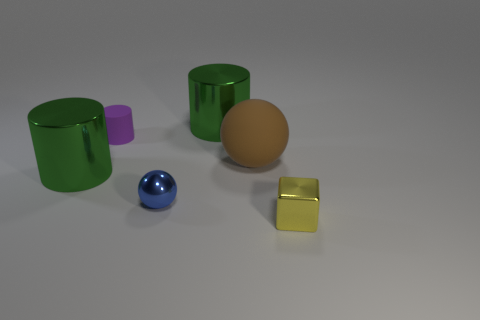Add 1 gray spheres. How many objects exist? 7 Subtract all balls. How many objects are left? 4 Subtract 0 cyan spheres. How many objects are left? 6 Subtract all rubber objects. Subtract all purple things. How many objects are left? 3 Add 2 small purple rubber cylinders. How many small purple rubber cylinders are left? 3 Add 2 big cyan matte cubes. How many big cyan matte cubes exist? 2 